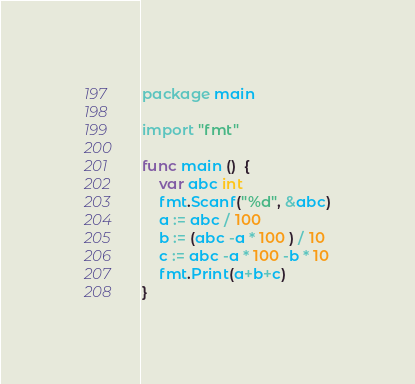Convert code to text. <code><loc_0><loc_0><loc_500><loc_500><_Go_>package main

import "fmt"

func main ()  {
	var abc int
	fmt.Scanf("%d", &abc)
	a := abc / 100
	b := (abc -a * 100 ) / 10
	c := abc -a * 100 -b * 10
	fmt.Print(a+b+c)
}</code> 